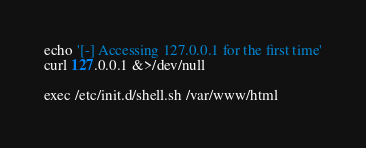Convert code to text. <code><loc_0><loc_0><loc_500><loc_500><_Bash_>echo '[-] Accessing 127.0.0.1 for the first time'
curl 127.0.0.1 &>/dev/null

exec /etc/init.d/shell.sh /var/www/html
</code> 